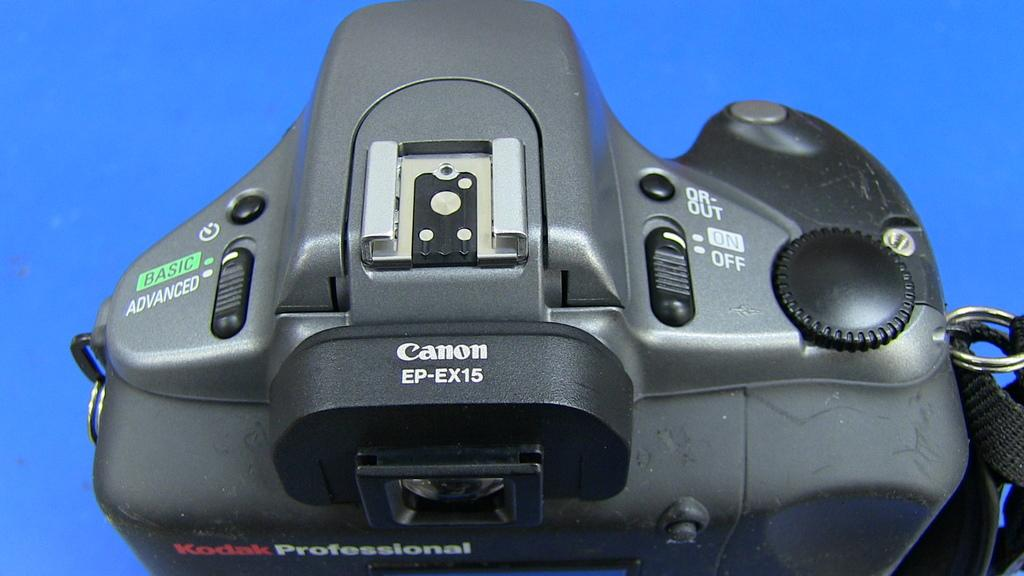<image>
Summarize the visual content of the image. The top of a grey canon digital camera with a blue background. 